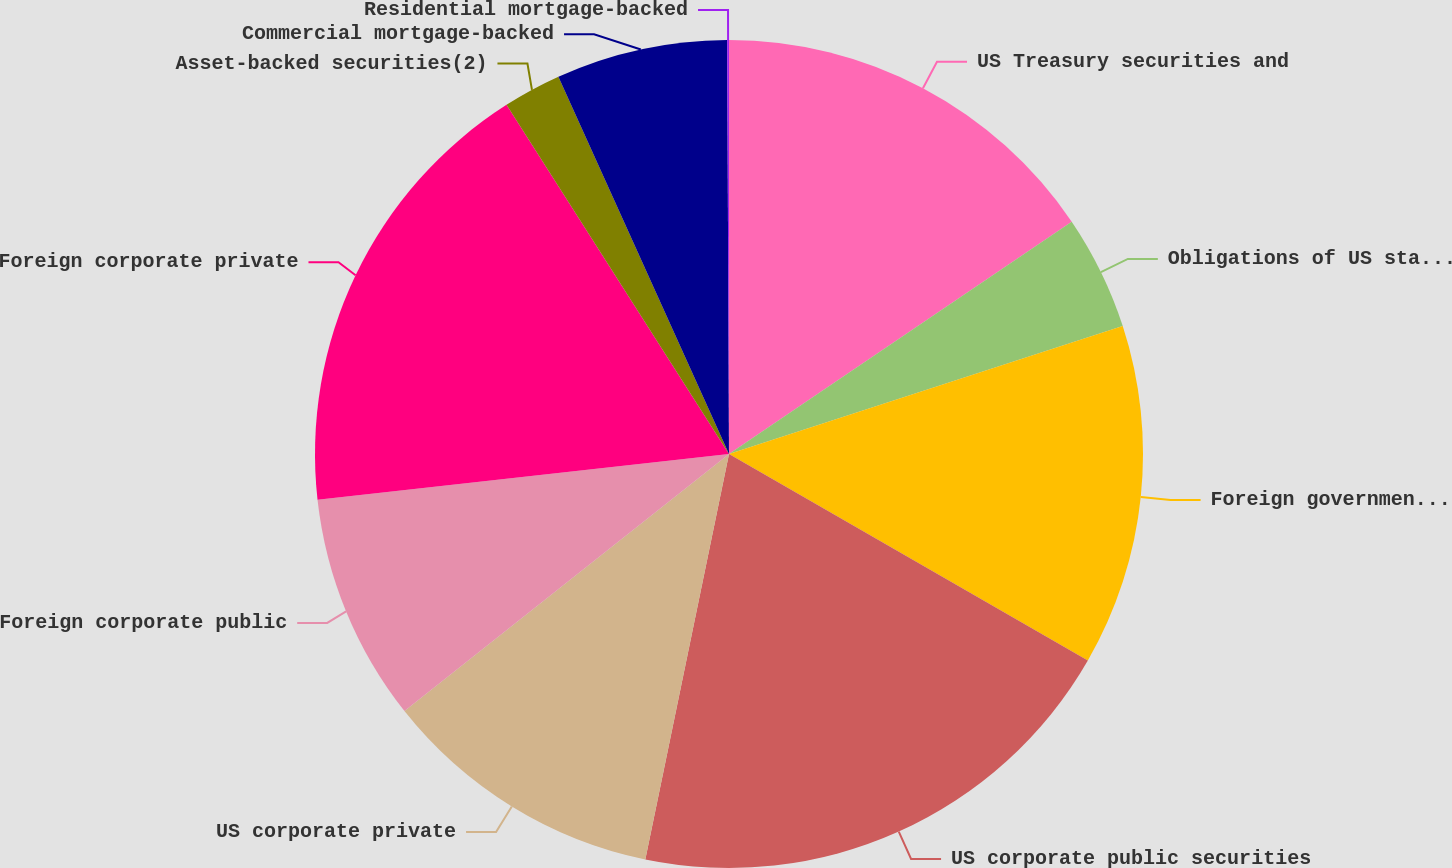<chart> <loc_0><loc_0><loc_500><loc_500><pie_chart><fcel>US Treasury securities and<fcel>Obligations of US states and<fcel>Foreign government bonds<fcel>US corporate public securities<fcel>US corporate private<fcel>Foreign corporate public<fcel>Foreign corporate private<fcel>Asset-backed securities(2)<fcel>Commercial mortgage-backed<fcel>Residential mortgage-backed<nl><fcel>15.52%<fcel>4.48%<fcel>13.31%<fcel>19.93%<fcel>11.1%<fcel>8.9%<fcel>17.73%<fcel>2.27%<fcel>6.69%<fcel>0.07%<nl></chart> 